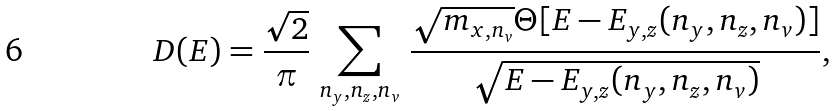Convert formula to latex. <formula><loc_0><loc_0><loc_500><loc_500>D ( E ) = \frac { \sqrt { 2 } } { \pi } \, \sum _ { n _ { y } , n _ { z } , n _ { v } } \, \frac { \sqrt { m _ { x , n _ { v } } } \Theta [ { E - E _ { y , z } ( n _ { y } , n _ { z } , n _ { v } ) } ] } { \sqrt { E - E _ { y , z } ( n _ { y } , n _ { z } , n _ { v } ) } } ,</formula> 